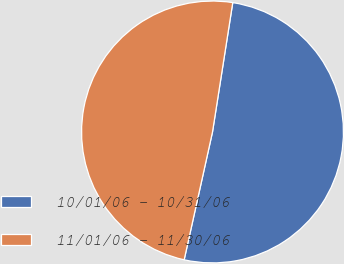Convert chart. <chart><loc_0><loc_0><loc_500><loc_500><pie_chart><fcel>10/01/06 - 10/31/06<fcel>11/01/06 - 11/30/06<nl><fcel>51.0%<fcel>49.0%<nl></chart> 